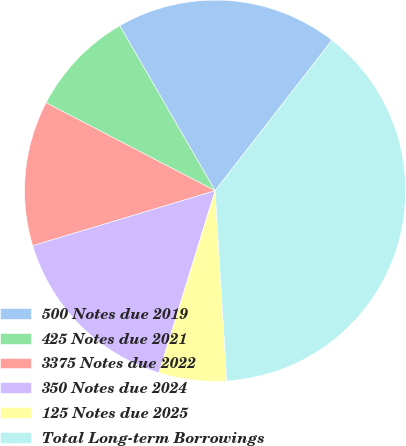<chart> <loc_0><loc_0><loc_500><loc_500><pie_chart><fcel>500 Notes due 2019<fcel>425 Notes due 2021<fcel>3375 Notes due 2022<fcel>350 Notes due 2024<fcel>125 Notes due 2025<fcel>Total Long-term Borrowings<nl><fcel>18.85%<fcel>9.02%<fcel>12.3%<fcel>15.57%<fcel>5.74%<fcel>38.52%<nl></chart> 